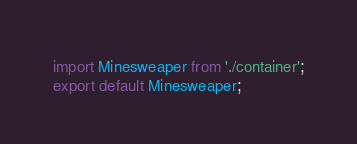<code> <loc_0><loc_0><loc_500><loc_500><_TypeScript_>import Minesweaper from './container';
export default Minesweaper;</code> 